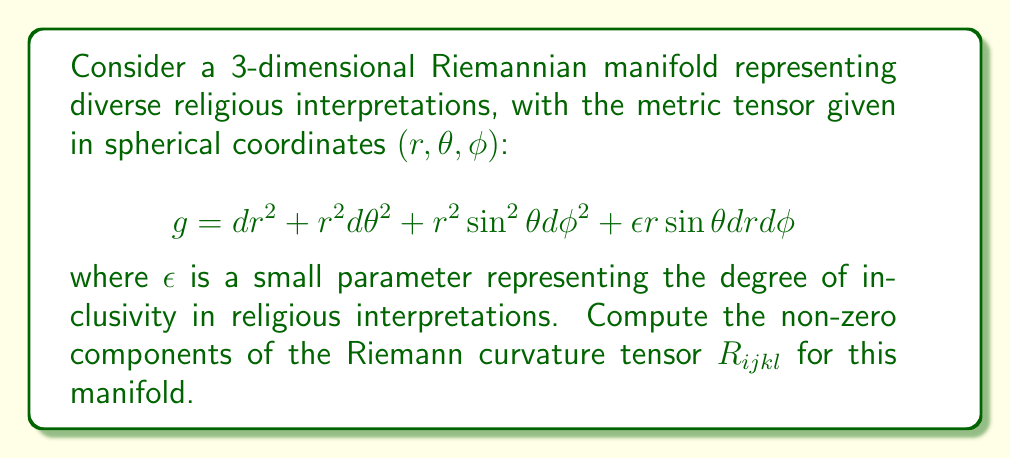Help me with this question. To compute the Riemann curvature tensor, we'll follow these steps:

1) First, we need to calculate the Christoffel symbols $\Gamma^i_{jk}$ using the formula:

   $$\Gamma^i_{jk} = \frac{1}{2}g^{im}(\partial_j g_{km} + \partial_k g_{jm} - \partial_m g_{jk})$$

2) The non-zero Christoffel symbols are:

   $$\Gamma^r_{\theta\theta} = -r$$
   $$\Gamma^r_{\phi\phi} = -r\sin^2\theta + \frac{1}{2}\epsilon\sin\theta$$
   $$\Gamma^\theta_{r\theta} = \Gamma^\theta_{\theta r} = \frac{1}{r}$$
   $$\Gamma^\theta_{\phi\phi} = -\sin\theta\cos\theta$$
   $$\Gamma^\phi_{r\phi} = \Gamma^\phi_{\phi r} = \frac{1}{r} + \frac{\epsilon}{2r^2\sin\theta}$$
   $$\Gamma^\phi_{\theta\phi} = \Gamma^\phi_{\phi\theta} = \cot\theta$$

3) Now, we can calculate the Riemann curvature tensor using the formula:

   $$R^i_{jkl} = \partial_k \Gamma^i_{jl} - \partial_l \Gamma^i_{jk} + \Gamma^m_{jl}\Gamma^i_{mk} - \Gamma^m_{jk}\Gamma^i_{ml}$$

4) The non-zero components of the Riemann curvature tensor are:

   $$R_{r\theta r\theta} = 1$$
   $$R_{r\phi r\phi} = \sin^2\theta - \frac{\epsilon}{2r}\sin\theta$$
   $$R_{\theta\phi\theta\phi} = r^2\sin^2\theta - \frac{\epsilon r}{2}\sin\theta$$

5) These components represent the curvature of the manifold in different directions, reflecting how diverse religious interpretations interact and influence each other in this mathematical model.
Answer: $$R_{r\theta r\theta} = 1, R_{r\phi r\phi} = \sin^2\theta - \frac{\epsilon}{2r}\sin\theta, R_{\theta\phi\theta\phi} = r^2\sin^2\theta - \frac{\epsilon r}{2}\sin\theta$$ 